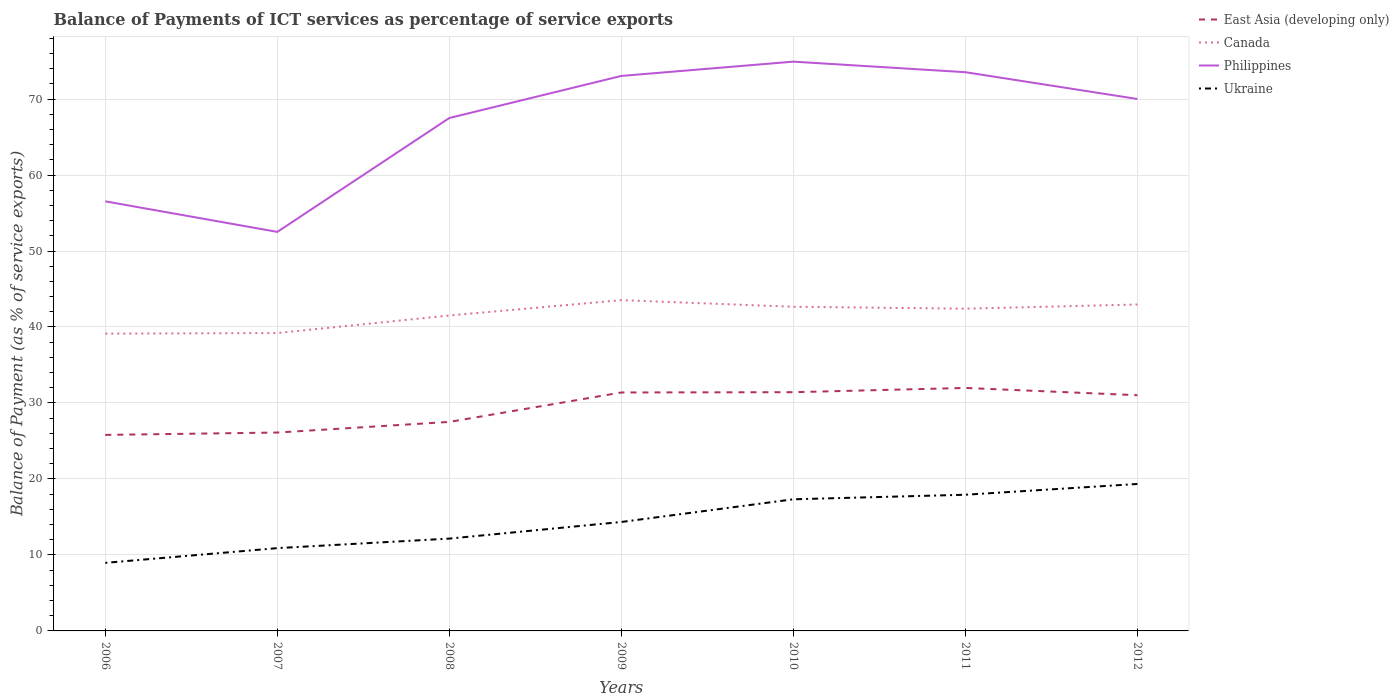Is the number of lines equal to the number of legend labels?
Your response must be concise. Yes. Across all years, what is the maximum balance of payments of ICT services in Canada?
Offer a terse response. 39.12. In which year was the balance of payments of ICT services in Ukraine maximum?
Offer a terse response. 2006. What is the total balance of payments of ICT services in Ukraine in the graph?
Offer a terse response. -0.6. What is the difference between the highest and the second highest balance of payments of ICT services in Canada?
Offer a terse response. 4.41. What is the difference between the highest and the lowest balance of payments of ICT services in East Asia (developing only)?
Ensure brevity in your answer.  4. What is the difference between two consecutive major ticks on the Y-axis?
Give a very brief answer. 10. Are the values on the major ticks of Y-axis written in scientific E-notation?
Your answer should be compact. No. Does the graph contain any zero values?
Provide a short and direct response. No. Does the graph contain grids?
Give a very brief answer. Yes. Where does the legend appear in the graph?
Provide a succinct answer. Top right. How many legend labels are there?
Your answer should be compact. 4. What is the title of the graph?
Provide a short and direct response. Balance of Payments of ICT services as percentage of service exports. What is the label or title of the Y-axis?
Keep it short and to the point. Balance of Payment (as % of service exports). What is the Balance of Payment (as % of service exports) in East Asia (developing only) in 2006?
Your answer should be compact. 25.8. What is the Balance of Payment (as % of service exports) of Canada in 2006?
Offer a very short reply. 39.12. What is the Balance of Payment (as % of service exports) in Philippines in 2006?
Provide a succinct answer. 56.53. What is the Balance of Payment (as % of service exports) of Ukraine in 2006?
Provide a succinct answer. 8.96. What is the Balance of Payment (as % of service exports) of East Asia (developing only) in 2007?
Offer a very short reply. 26.11. What is the Balance of Payment (as % of service exports) in Canada in 2007?
Your answer should be very brief. 39.2. What is the Balance of Payment (as % of service exports) in Philippines in 2007?
Offer a very short reply. 52.51. What is the Balance of Payment (as % of service exports) of Ukraine in 2007?
Make the answer very short. 10.9. What is the Balance of Payment (as % of service exports) in East Asia (developing only) in 2008?
Keep it short and to the point. 27.51. What is the Balance of Payment (as % of service exports) of Canada in 2008?
Your answer should be very brief. 41.51. What is the Balance of Payment (as % of service exports) of Philippines in 2008?
Your response must be concise. 67.5. What is the Balance of Payment (as % of service exports) of Ukraine in 2008?
Offer a terse response. 12.15. What is the Balance of Payment (as % of service exports) in East Asia (developing only) in 2009?
Provide a short and direct response. 31.38. What is the Balance of Payment (as % of service exports) of Canada in 2009?
Provide a short and direct response. 43.53. What is the Balance of Payment (as % of service exports) of Philippines in 2009?
Give a very brief answer. 73.04. What is the Balance of Payment (as % of service exports) in Ukraine in 2009?
Provide a short and direct response. 14.34. What is the Balance of Payment (as % of service exports) of East Asia (developing only) in 2010?
Offer a terse response. 31.42. What is the Balance of Payment (as % of service exports) of Canada in 2010?
Offer a terse response. 42.66. What is the Balance of Payment (as % of service exports) of Philippines in 2010?
Make the answer very short. 74.92. What is the Balance of Payment (as % of service exports) of Ukraine in 2010?
Ensure brevity in your answer.  17.32. What is the Balance of Payment (as % of service exports) in East Asia (developing only) in 2011?
Your answer should be compact. 31.98. What is the Balance of Payment (as % of service exports) of Canada in 2011?
Offer a very short reply. 42.41. What is the Balance of Payment (as % of service exports) of Philippines in 2011?
Keep it short and to the point. 73.53. What is the Balance of Payment (as % of service exports) of Ukraine in 2011?
Give a very brief answer. 17.92. What is the Balance of Payment (as % of service exports) in East Asia (developing only) in 2012?
Your answer should be compact. 31.02. What is the Balance of Payment (as % of service exports) of Canada in 2012?
Ensure brevity in your answer.  42.96. What is the Balance of Payment (as % of service exports) in Philippines in 2012?
Give a very brief answer. 70.01. What is the Balance of Payment (as % of service exports) in Ukraine in 2012?
Provide a succinct answer. 19.34. Across all years, what is the maximum Balance of Payment (as % of service exports) of East Asia (developing only)?
Give a very brief answer. 31.98. Across all years, what is the maximum Balance of Payment (as % of service exports) of Canada?
Make the answer very short. 43.53. Across all years, what is the maximum Balance of Payment (as % of service exports) of Philippines?
Make the answer very short. 74.92. Across all years, what is the maximum Balance of Payment (as % of service exports) in Ukraine?
Your answer should be compact. 19.34. Across all years, what is the minimum Balance of Payment (as % of service exports) of East Asia (developing only)?
Offer a terse response. 25.8. Across all years, what is the minimum Balance of Payment (as % of service exports) of Canada?
Your response must be concise. 39.12. Across all years, what is the minimum Balance of Payment (as % of service exports) of Philippines?
Make the answer very short. 52.51. Across all years, what is the minimum Balance of Payment (as % of service exports) of Ukraine?
Provide a succinct answer. 8.96. What is the total Balance of Payment (as % of service exports) of East Asia (developing only) in the graph?
Offer a terse response. 205.21. What is the total Balance of Payment (as % of service exports) of Canada in the graph?
Your response must be concise. 291.4. What is the total Balance of Payment (as % of service exports) in Philippines in the graph?
Give a very brief answer. 468.05. What is the total Balance of Payment (as % of service exports) of Ukraine in the graph?
Provide a succinct answer. 100.93. What is the difference between the Balance of Payment (as % of service exports) of East Asia (developing only) in 2006 and that in 2007?
Offer a terse response. -0.31. What is the difference between the Balance of Payment (as % of service exports) in Canada in 2006 and that in 2007?
Make the answer very short. -0.08. What is the difference between the Balance of Payment (as % of service exports) of Philippines in 2006 and that in 2007?
Ensure brevity in your answer.  4.02. What is the difference between the Balance of Payment (as % of service exports) in Ukraine in 2006 and that in 2007?
Keep it short and to the point. -1.94. What is the difference between the Balance of Payment (as % of service exports) in East Asia (developing only) in 2006 and that in 2008?
Offer a very short reply. -1.71. What is the difference between the Balance of Payment (as % of service exports) of Canada in 2006 and that in 2008?
Ensure brevity in your answer.  -2.39. What is the difference between the Balance of Payment (as % of service exports) of Philippines in 2006 and that in 2008?
Provide a short and direct response. -10.97. What is the difference between the Balance of Payment (as % of service exports) in Ukraine in 2006 and that in 2008?
Your answer should be very brief. -3.19. What is the difference between the Balance of Payment (as % of service exports) in East Asia (developing only) in 2006 and that in 2009?
Keep it short and to the point. -5.58. What is the difference between the Balance of Payment (as % of service exports) of Canada in 2006 and that in 2009?
Offer a terse response. -4.41. What is the difference between the Balance of Payment (as % of service exports) of Philippines in 2006 and that in 2009?
Provide a succinct answer. -16.51. What is the difference between the Balance of Payment (as % of service exports) of Ukraine in 2006 and that in 2009?
Provide a short and direct response. -5.38. What is the difference between the Balance of Payment (as % of service exports) of East Asia (developing only) in 2006 and that in 2010?
Your response must be concise. -5.62. What is the difference between the Balance of Payment (as % of service exports) in Canada in 2006 and that in 2010?
Provide a short and direct response. -3.54. What is the difference between the Balance of Payment (as % of service exports) in Philippines in 2006 and that in 2010?
Provide a short and direct response. -18.39. What is the difference between the Balance of Payment (as % of service exports) in Ukraine in 2006 and that in 2010?
Offer a very short reply. -8.37. What is the difference between the Balance of Payment (as % of service exports) of East Asia (developing only) in 2006 and that in 2011?
Keep it short and to the point. -6.18. What is the difference between the Balance of Payment (as % of service exports) in Canada in 2006 and that in 2011?
Make the answer very short. -3.29. What is the difference between the Balance of Payment (as % of service exports) of Philippines in 2006 and that in 2011?
Provide a succinct answer. -17. What is the difference between the Balance of Payment (as % of service exports) of Ukraine in 2006 and that in 2011?
Your response must be concise. -8.97. What is the difference between the Balance of Payment (as % of service exports) in East Asia (developing only) in 2006 and that in 2012?
Offer a very short reply. -5.22. What is the difference between the Balance of Payment (as % of service exports) of Canada in 2006 and that in 2012?
Offer a terse response. -3.84. What is the difference between the Balance of Payment (as % of service exports) in Philippines in 2006 and that in 2012?
Make the answer very short. -13.47. What is the difference between the Balance of Payment (as % of service exports) in Ukraine in 2006 and that in 2012?
Offer a very short reply. -10.38. What is the difference between the Balance of Payment (as % of service exports) in East Asia (developing only) in 2007 and that in 2008?
Provide a succinct answer. -1.4. What is the difference between the Balance of Payment (as % of service exports) of Canada in 2007 and that in 2008?
Your response must be concise. -2.31. What is the difference between the Balance of Payment (as % of service exports) of Philippines in 2007 and that in 2008?
Provide a short and direct response. -14.99. What is the difference between the Balance of Payment (as % of service exports) in Ukraine in 2007 and that in 2008?
Make the answer very short. -1.25. What is the difference between the Balance of Payment (as % of service exports) of East Asia (developing only) in 2007 and that in 2009?
Offer a very short reply. -5.27. What is the difference between the Balance of Payment (as % of service exports) of Canada in 2007 and that in 2009?
Make the answer very short. -4.33. What is the difference between the Balance of Payment (as % of service exports) of Philippines in 2007 and that in 2009?
Provide a short and direct response. -20.53. What is the difference between the Balance of Payment (as % of service exports) of Ukraine in 2007 and that in 2009?
Provide a succinct answer. -3.44. What is the difference between the Balance of Payment (as % of service exports) of East Asia (developing only) in 2007 and that in 2010?
Keep it short and to the point. -5.31. What is the difference between the Balance of Payment (as % of service exports) in Canada in 2007 and that in 2010?
Ensure brevity in your answer.  -3.46. What is the difference between the Balance of Payment (as % of service exports) in Philippines in 2007 and that in 2010?
Make the answer very short. -22.41. What is the difference between the Balance of Payment (as % of service exports) of Ukraine in 2007 and that in 2010?
Keep it short and to the point. -6.43. What is the difference between the Balance of Payment (as % of service exports) of East Asia (developing only) in 2007 and that in 2011?
Offer a very short reply. -5.87. What is the difference between the Balance of Payment (as % of service exports) in Canada in 2007 and that in 2011?
Give a very brief answer. -3.2. What is the difference between the Balance of Payment (as % of service exports) in Philippines in 2007 and that in 2011?
Make the answer very short. -21.02. What is the difference between the Balance of Payment (as % of service exports) in Ukraine in 2007 and that in 2011?
Provide a succinct answer. -7.03. What is the difference between the Balance of Payment (as % of service exports) of East Asia (developing only) in 2007 and that in 2012?
Ensure brevity in your answer.  -4.91. What is the difference between the Balance of Payment (as % of service exports) in Canada in 2007 and that in 2012?
Make the answer very short. -3.76. What is the difference between the Balance of Payment (as % of service exports) in Philippines in 2007 and that in 2012?
Ensure brevity in your answer.  -17.49. What is the difference between the Balance of Payment (as % of service exports) of Ukraine in 2007 and that in 2012?
Offer a very short reply. -8.44. What is the difference between the Balance of Payment (as % of service exports) in East Asia (developing only) in 2008 and that in 2009?
Keep it short and to the point. -3.87. What is the difference between the Balance of Payment (as % of service exports) of Canada in 2008 and that in 2009?
Make the answer very short. -2.02. What is the difference between the Balance of Payment (as % of service exports) in Philippines in 2008 and that in 2009?
Give a very brief answer. -5.54. What is the difference between the Balance of Payment (as % of service exports) of Ukraine in 2008 and that in 2009?
Offer a very short reply. -2.19. What is the difference between the Balance of Payment (as % of service exports) in East Asia (developing only) in 2008 and that in 2010?
Offer a terse response. -3.91. What is the difference between the Balance of Payment (as % of service exports) in Canada in 2008 and that in 2010?
Provide a succinct answer. -1.15. What is the difference between the Balance of Payment (as % of service exports) in Philippines in 2008 and that in 2010?
Make the answer very short. -7.42. What is the difference between the Balance of Payment (as % of service exports) of Ukraine in 2008 and that in 2010?
Your answer should be compact. -5.17. What is the difference between the Balance of Payment (as % of service exports) of East Asia (developing only) in 2008 and that in 2011?
Offer a very short reply. -4.47. What is the difference between the Balance of Payment (as % of service exports) in Canada in 2008 and that in 2011?
Provide a succinct answer. -0.9. What is the difference between the Balance of Payment (as % of service exports) in Philippines in 2008 and that in 2011?
Your answer should be very brief. -6.03. What is the difference between the Balance of Payment (as % of service exports) of Ukraine in 2008 and that in 2011?
Your answer should be compact. -5.77. What is the difference between the Balance of Payment (as % of service exports) in East Asia (developing only) in 2008 and that in 2012?
Ensure brevity in your answer.  -3.51. What is the difference between the Balance of Payment (as % of service exports) in Canada in 2008 and that in 2012?
Keep it short and to the point. -1.45. What is the difference between the Balance of Payment (as % of service exports) of Philippines in 2008 and that in 2012?
Provide a short and direct response. -2.5. What is the difference between the Balance of Payment (as % of service exports) in Ukraine in 2008 and that in 2012?
Make the answer very short. -7.19. What is the difference between the Balance of Payment (as % of service exports) in East Asia (developing only) in 2009 and that in 2010?
Your answer should be compact. -0.04. What is the difference between the Balance of Payment (as % of service exports) of Canada in 2009 and that in 2010?
Your answer should be very brief. 0.87. What is the difference between the Balance of Payment (as % of service exports) of Philippines in 2009 and that in 2010?
Ensure brevity in your answer.  -1.88. What is the difference between the Balance of Payment (as % of service exports) in Ukraine in 2009 and that in 2010?
Make the answer very short. -2.99. What is the difference between the Balance of Payment (as % of service exports) in East Asia (developing only) in 2009 and that in 2011?
Your answer should be very brief. -0.6. What is the difference between the Balance of Payment (as % of service exports) in Canada in 2009 and that in 2011?
Provide a short and direct response. 1.12. What is the difference between the Balance of Payment (as % of service exports) in Philippines in 2009 and that in 2011?
Offer a terse response. -0.49. What is the difference between the Balance of Payment (as % of service exports) of Ukraine in 2009 and that in 2011?
Your response must be concise. -3.58. What is the difference between the Balance of Payment (as % of service exports) of East Asia (developing only) in 2009 and that in 2012?
Provide a short and direct response. 0.36. What is the difference between the Balance of Payment (as % of service exports) of Canada in 2009 and that in 2012?
Make the answer very short. 0.57. What is the difference between the Balance of Payment (as % of service exports) of Philippines in 2009 and that in 2012?
Keep it short and to the point. 3.03. What is the difference between the Balance of Payment (as % of service exports) in Ukraine in 2009 and that in 2012?
Ensure brevity in your answer.  -5. What is the difference between the Balance of Payment (as % of service exports) of East Asia (developing only) in 2010 and that in 2011?
Keep it short and to the point. -0.56. What is the difference between the Balance of Payment (as % of service exports) in Canada in 2010 and that in 2011?
Offer a very short reply. 0.25. What is the difference between the Balance of Payment (as % of service exports) in Philippines in 2010 and that in 2011?
Provide a short and direct response. 1.39. What is the difference between the Balance of Payment (as % of service exports) in Ukraine in 2010 and that in 2011?
Ensure brevity in your answer.  -0.6. What is the difference between the Balance of Payment (as % of service exports) of East Asia (developing only) in 2010 and that in 2012?
Offer a terse response. 0.4. What is the difference between the Balance of Payment (as % of service exports) of Canada in 2010 and that in 2012?
Your answer should be very brief. -0.3. What is the difference between the Balance of Payment (as % of service exports) in Philippines in 2010 and that in 2012?
Your response must be concise. 4.92. What is the difference between the Balance of Payment (as % of service exports) of Ukraine in 2010 and that in 2012?
Offer a very short reply. -2.02. What is the difference between the Balance of Payment (as % of service exports) in East Asia (developing only) in 2011 and that in 2012?
Give a very brief answer. 0.96. What is the difference between the Balance of Payment (as % of service exports) in Canada in 2011 and that in 2012?
Give a very brief answer. -0.55. What is the difference between the Balance of Payment (as % of service exports) in Philippines in 2011 and that in 2012?
Your response must be concise. 3.53. What is the difference between the Balance of Payment (as % of service exports) of Ukraine in 2011 and that in 2012?
Offer a very short reply. -1.42. What is the difference between the Balance of Payment (as % of service exports) in East Asia (developing only) in 2006 and the Balance of Payment (as % of service exports) in Canada in 2007?
Give a very brief answer. -13.41. What is the difference between the Balance of Payment (as % of service exports) in East Asia (developing only) in 2006 and the Balance of Payment (as % of service exports) in Philippines in 2007?
Your answer should be compact. -26.72. What is the difference between the Balance of Payment (as % of service exports) in East Asia (developing only) in 2006 and the Balance of Payment (as % of service exports) in Ukraine in 2007?
Give a very brief answer. 14.9. What is the difference between the Balance of Payment (as % of service exports) in Canada in 2006 and the Balance of Payment (as % of service exports) in Philippines in 2007?
Your answer should be compact. -13.39. What is the difference between the Balance of Payment (as % of service exports) of Canada in 2006 and the Balance of Payment (as % of service exports) of Ukraine in 2007?
Your answer should be very brief. 28.23. What is the difference between the Balance of Payment (as % of service exports) of Philippines in 2006 and the Balance of Payment (as % of service exports) of Ukraine in 2007?
Provide a succinct answer. 45.64. What is the difference between the Balance of Payment (as % of service exports) of East Asia (developing only) in 2006 and the Balance of Payment (as % of service exports) of Canada in 2008?
Your response must be concise. -15.71. What is the difference between the Balance of Payment (as % of service exports) of East Asia (developing only) in 2006 and the Balance of Payment (as % of service exports) of Philippines in 2008?
Keep it short and to the point. -41.7. What is the difference between the Balance of Payment (as % of service exports) in East Asia (developing only) in 2006 and the Balance of Payment (as % of service exports) in Ukraine in 2008?
Give a very brief answer. 13.65. What is the difference between the Balance of Payment (as % of service exports) in Canada in 2006 and the Balance of Payment (as % of service exports) in Philippines in 2008?
Your answer should be very brief. -28.38. What is the difference between the Balance of Payment (as % of service exports) of Canada in 2006 and the Balance of Payment (as % of service exports) of Ukraine in 2008?
Keep it short and to the point. 26.97. What is the difference between the Balance of Payment (as % of service exports) of Philippines in 2006 and the Balance of Payment (as % of service exports) of Ukraine in 2008?
Your response must be concise. 44.38. What is the difference between the Balance of Payment (as % of service exports) in East Asia (developing only) in 2006 and the Balance of Payment (as % of service exports) in Canada in 2009?
Keep it short and to the point. -17.73. What is the difference between the Balance of Payment (as % of service exports) of East Asia (developing only) in 2006 and the Balance of Payment (as % of service exports) of Philippines in 2009?
Make the answer very short. -47.24. What is the difference between the Balance of Payment (as % of service exports) in East Asia (developing only) in 2006 and the Balance of Payment (as % of service exports) in Ukraine in 2009?
Ensure brevity in your answer.  11.46. What is the difference between the Balance of Payment (as % of service exports) in Canada in 2006 and the Balance of Payment (as % of service exports) in Philippines in 2009?
Your answer should be very brief. -33.92. What is the difference between the Balance of Payment (as % of service exports) of Canada in 2006 and the Balance of Payment (as % of service exports) of Ukraine in 2009?
Offer a very short reply. 24.78. What is the difference between the Balance of Payment (as % of service exports) in Philippines in 2006 and the Balance of Payment (as % of service exports) in Ukraine in 2009?
Keep it short and to the point. 42.2. What is the difference between the Balance of Payment (as % of service exports) of East Asia (developing only) in 2006 and the Balance of Payment (as % of service exports) of Canada in 2010?
Provide a short and direct response. -16.86. What is the difference between the Balance of Payment (as % of service exports) in East Asia (developing only) in 2006 and the Balance of Payment (as % of service exports) in Philippines in 2010?
Provide a short and direct response. -49.12. What is the difference between the Balance of Payment (as % of service exports) of East Asia (developing only) in 2006 and the Balance of Payment (as % of service exports) of Ukraine in 2010?
Your response must be concise. 8.47. What is the difference between the Balance of Payment (as % of service exports) in Canada in 2006 and the Balance of Payment (as % of service exports) in Philippines in 2010?
Keep it short and to the point. -35.8. What is the difference between the Balance of Payment (as % of service exports) of Canada in 2006 and the Balance of Payment (as % of service exports) of Ukraine in 2010?
Your answer should be compact. 21.8. What is the difference between the Balance of Payment (as % of service exports) in Philippines in 2006 and the Balance of Payment (as % of service exports) in Ukraine in 2010?
Make the answer very short. 39.21. What is the difference between the Balance of Payment (as % of service exports) in East Asia (developing only) in 2006 and the Balance of Payment (as % of service exports) in Canada in 2011?
Provide a succinct answer. -16.61. What is the difference between the Balance of Payment (as % of service exports) of East Asia (developing only) in 2006 and the Balance of Payment (as % of service exports) of Philippines in 2011?
Your answer should be very brief. -47.73. What is the difference between the Balance of Payment (as % of service exports) of East Asia (developing only) in 2006 and the Balance of Payment (as % of service exports) of Ukraine in 2011?
Provide a short and direct response. 7.88. What is the difference between the Balance of Payment (as % of service exports) in Canada in 2006 and the Balance of Payment (as % of service exports) in Philippines in 2011?
Your answer should be very brief. -34.41. What is the difference between the Balance of Payment (as % of service exports) of Canada in 2006 and the Balance of Payment (as % of service exports) of Ukraine in 2011?
Provide a short and direct response. 21.2. What is the difference between the Balance of Payment (as % of service exports) in Philippines in 2006 and the Balance of Payment (as % of service exports) in Ukraine in 2011?
Provide a short and direct response. 38.61. What is the difference between the Balance of Payment (as % of service exports) of East Asia (developing only) in 2006 and the Balance of Payment (as % of service exports) of Canada in 2012?
Make the answer very short. -17.16. What is the difference between the Balance of Payment (as % of service exports) of East Asia (developing only) in 2006 and the Balance of Payment (as % of service exports) of Philippines in 2012?
Your response must be concise. -44.21. What is the difference between the Balance of Payment (as % of service exports) of East Asia (developing only) in 2006 and the Balance of Payment (as % of service exports) of Ukraine in 2012?
Make the answer very short. 6.46. What is the difference between the Balance of Payment (as % of service exports) of Canada in 2006 and the Balance of Payment (as % of service exports) of Philippines in 2012?
Make the answer very short. -30.88. What is the difference between the Balance of Payment (as % of service exports) of Canada in 2006 and the Balance of Payment (as % of service exports) of Ukraine in 2012?
Provide a short and direct response. 19.78. What is the difference between the Balance of Payment (as % of service exports) in Philippines in 2006 and the Balance of Payment (as % of service exports) in Ukraine in 2012?
Provide a succinct answer. 37.19. What is the difference between the Balance of Payment (as % of service exports) in East Asia (developing only) in 2007 and the Balance of Payment (as % of service exports) in Canada in 2008?
Give a very brief answer. -15.4. What is the difference between the Balance of Payment (as % of service exports) in East Asia (developing only) in 2007 and the Balance of Payment (as % of service exports) in Philippines in 2008?
Offer a terse response. -41.39. What is the difference between the Balance of Payment (as % of service exports) in East Asia (developing only) in 2007 and the Balance of Payment (as % of service exports) in Ukraine in 2008?
Provide a succinct answer. 13.96. What is the difference between the Balance of Payment (as % of service exports) of Canada in 2007 and the Balance of Payment (as % of service exports) of Philippines in 2008?
Make the answer very short. -28.3. What is the difference between the Balance of Payment (as % of service exports) in Canada in 2007 and the Balance of Payment (as % of service exports) in Ukraine in 2008?
Make the answer very short. 27.05. What is the difference between the Balance of Payment (as % of service exports) in Philippines in 2007 and the Balance of Payment (as % of service exports) in Ukraine in 2008?
Make the answer very short. 40.36. What is the difference between the Balance of Payment (as % of service exports) of East Asia (developing only) in 2007 and the Balance of Payment (as % of service exports) of Canada in 2009?
Make the answer very short. -17.42. What is the difference between the Balance of Payment (as % of service exports) of East Asia (developing only) in 2007 and the Balance of Payment (as % of service exports) of Philippines in 2009?
Your response must be concise. -46.93. What is the difference between the Balance of Payment (as % of service exports) of East Asia (developing only) in 2007 and the Balance of Payment (as % of service exports) of Ukraine in 2009?
Your answer should be very brief. 11.77. What is the difference between the Balance of Payment (as % of service exports) in Canada in 2007 and the Balance of Payment (as % of service exports) in Philippines in 2009?
Ensure brevity in your answer.  -33.84. What is the difference between the Balance of Payment (as % of service exports) in Canada in 2007 and the Balance of Payment (as % of service exports) in Ukraine in 2009?
Provide a succinct answer. 24.87. What is the difference between the Balance of Payment (as % of service exports) of Philippines in 2007 and the Balance of Payment (as % of service exports) of Ukraine in 2009?
Keep it short and to the point. 38.18. What is the difference between the Balance of Payment (as % of service exports) in East Asia (developing only) in 2007 and the Balance of Payment (as % of service exports) in Canada in 2010?
Ensure brevity in your answer.  -16.55. What is the difference between the Balance of Payment (as % of service exports) in East Asia (developing only) in 2007 and the Balance of Payment (as % of service exports) in Philippines in 2010?
Keep it short and to the point. -48.81. What is the difference between the Balance of Payment (as % of service exports) in East Asia (developing only) in 2007 and the Balance of Payment (as % of service exports) in Ukraine in 2010?
Make the answer very short. 8.78. What is the difference between the Balance of Payment (as % of service exports) in Canada in 2007 and the Balance of Payment (as % of service exports) in Philippines in 2010?
Offer a terse response. -35.72. What is the difference between the Balance of Payment (as % of service exports) of Canada in 2007 and the Balance of Payment (as % of service exports) of Ukraine in 2010?
Your answer should be compact. 21.88. What is the difference between the Balance of Payment (as % of service exports) of Philippines in 2007 and the Balance of Payment (as % of service exports) of Ukraine in 2010?
Ensure brevity in your answer.  35.19. What is the difference between the Balance of Payment (as % of service exports) of East Asia (developing only) in 2007 and the Balance of Payment (as % of service exports) of Canada in 2011?
Your response must be concise. -16.3. What is the difference between the Balance of Payment (as % of service exports) in East Asia (developing only) in 2007 and the Balance of Payment (as % of service exports) in Philippines in 2011?
Provide a short and direct response. -47.42. What is the difference between the Balance of Payment (as % of service exports) in East Asia (developing only) in 2007 and the Balance of Payment (as % of service exports) in Ukraine in 2011?
Make the answer very short. 8.19. What is the difference between the Balance of Payment (as % of service exports) in Canada in 2007 and the Balance of Payment (as % of service exports) in Philippines in 2011?
Give a very brief answer. -34.33. What is the difference between the Balance of Payment (as % of service exports) of Canada in 2007 and the Balance of Payment (as % of service exports) of Ukraine in 2011?
Offer a terse response. 21.28. What is the difference between the Balance of Payment (as % of service exports) in Philippines in 2007 and the Balance of Payment (as % of service exports) in Ukraine in 2011?
Provide a succinct answer. 34.59. What is the difference between the Balance of Payment (as % of service exports) of East Asia (developing only) in 2007 and the Balance of Payment (as % of service exports) of Canada in 2012?
Your answer should be very brief. -16.85. What is the difference between the Balance of Payment (as % of service exports) in East Asia (developing only) in 2007 and the Balance of Payment (as % of service exports) in Philippines in 2012?
Your response must be concise. -43.9. What is the difference between the Balance of Payment (as % of service exports) in East Asia (developing only) in 2007 and the Balance of Payment (as % of service exports) in Ukraine in 2012?
Keep it short and to the point. 6.77. What is the difference between the Balance of Payment (as % of service exports) of Canada in 2007 and the Balance of Payment (as % of service exports) of Philippines in 2012?
Keep it short and to the point. -30.8. What is the difference between the Balance of Payment (as % of service exports) of Canada in 2007 and the Balance of Payment (as % of service exports) of Ukraine in 2012?
Provide a succinct answer. 19.86. What is the difference between the Balance of Payment (as % of service exports) in Philippines in 2007 and the Balance of Payment (as % of service exports) in Ukraine in 2012?
Provide a short and direct response. 33.17. What is the difference between the Balance of Payment (as % of service exports) of East Asia (developing only) in 2008 and the Balance of Payment (as % of service exports) of Canada in 2009?
Provide a succinct answer. -16.02. What is the difference between the Balance of Payment (as % of service exports) of East Asia (developing only) in 2008 and the Balance of Payment (as % of service exports) of Philippines in 2009?
Your answer should be very brief. -45.53. What is the difference between the Balance of Payment (as % of service exports) in East Asia (developing only) in 2008 and the Balance of Payment (as % of service exports) in Ukraine in 2009?
Offer a terse response. 13.17. What is the difference between the Balance of Payment (as % of service exports) of Canada in 2008 and the Balance of Payment (as % of service exports) of Philippines in 2009?
Your answer should be compact. -31.53. What is the difference between the Balance of Payment (as % of service exports) in Canada in 2008 and the Balance of Payment (as % of service exports) in Ukraine in 2009?
Your answer should be very brief. 27.17. What is the difference between the Balance of Payment (as % of service exports) in Philippines in 2008 and the Balance of Payment (as % of service exports) in Ukraine in 2009?
Keep it short and to the point. 53.16. What is the difference between the Balance of Payment (as % of service exports) of East Asia (developing only) in 2008 and the Balance of Payment (as % of service exports) of Canada in 2010?
Provide a short and direct response. -15.15. What is the difference between the Balance of Payment (as % of service exports) in East Asia (developing only) in 2008 and the Balance of Payment (as % of service exports) in Philippines in 2010?
Give a very brief answer. -47.41. What is the difference between the Balance of Payment (as % of service exports) in East Asia (developing only) in 2008 and the Balance of Payment (as % of service exports) in Ukraine in 2010?
Ensure brevity in your answer.  10.18. What is the difference between the Balance of Payment (as % of service exports) of Canada in 2008 and the Balance of Payment (as % of service exports) of Philippines in 2010?
Your response must be concise. -33.41. What is the difference between the Balance of Payment (as % of service exports) of Canada in 2008 and the Balance of Payment (as % of service exports) of Ukraine in 2010?
Offer a very short reply. 24.19. What is the difference between the Balance of Payment (as % of service exports) in Philippines in 2008 and the Balance of Payment (as % of service exports) in Ukraine in 2010?
Keep it short and to the point. 50.18. What is the difference between the Balance of Payment (as % of service exports) in East Asia (developing only) in 2008 and the Balance of Payment (as % of service exports) in Canada in 2011?
Give a very brief answer. -14.9. What is the difference between the Balance of Payment (as % of service exports) of East Asia (developing only) in 2008 and the Balance of Payment (as % of service exports) of Philippines in 2011?
Provide a short and direct response. -46.02. What is the difference between the Balance of Payment (as % of service exports) in East Asia (developing only) in 2008 and the Balance of Payment (as % of service exports) in Ukraine in 2011?
Make the answer very short. 9.59. What is the difference between the Balance of Payment (as % of service exports) of Canada in 2008 and the Balance of Payment (as % of service exports) of Philippines in 2011?
Your answer should be compact. -32.02. What is the difference between the Balance of Payment (as % of service exports) of Canada in 2008 and the Balance of Payment (as % of service exports) of Ukraine in 2011?
Ensure brevity in your answer.  23.59. What is the difference between the Balance of Payment (as % of service exports) in Philippines in 2008 and the Balance of Payment (as % of service exports) in Ukraine in 2011?
Your answer should be compact. 49.58. What is the difference between the Balance of Payment (as % of service exports) of East Asia (developing only) in 2008 and the Balance of Payment (as % of service exports) of Canada in 2012?
Give a very brief answer. -15.45. What is the difference between the Balance of Payment (as % of service exports) of East Asia (developing only) in 2008 and the Balance of Payment (as % of service exports) of Philippines in 2012?
Provide a short and direct response. -42.5. What is the difference between the Balance of Payment (as % of service exports) of East Asia (developing only) in 2008 and the Balance of Payment (as % of service exports) of Ukraine in 2012?
Keep it short and to the point. 8.17. What is the difference between the Balance of Payment (as % of service exports) of Canada in 2008 and the Balance of Payment (as % of service exports) of Philippines in 2012?
Your answer should be compact. -28.5. What is the difference between the Balance of Payment (as % of service exports) of Canada in 2008 and the Balance of Payment (as % of service exports) of Ukraine in 2012?
Make the answer very short. 22.17. What is the difference between the Balance of Payment (as % of service exports) of Philippines in 2008 and the Balance of Payment (as % of service exports) of Ukraine in 2012?
Ensure brevity in your answer.  48.16. What is the difference between the Balance of Payment (as % of service exports) of East Asia (developing only) in 2009 and the Balance of Payment (as % of service exports) of Canada in 2010?
Make the answer very short. -11.28. What is the difference between the Balance of Payment (as % of service exports) in East Asia (developing only) in 2009 and the Balance of Payment (as % of service exports) in Philippines in 2010?
Offer a terse response. -43.54. What is the difference between the Balance of Payment (as % of service exports) of East Asia (developing only) in 2009 and the Balance of Payment (as % of service exports) of Ukraine in 2010?
Your response must be concise. 14.06. What is the difference between the Balance of Payment (as % of service exports) of Canada in 2009 and the Balance of Payment (as % of service exports) of Philippines in 2010?
Ensure brevity in your answer.  -31.39. What is the difference between the Balance of Payment (as % of service exports) in Canada in 2009 and the Balance of Payment (as % of service exports) in Ukraine in 2010?
Make the answer very short. 26.21. What is the difference between the Balance of Payment (as % of service exports) of Philippines in 2009 and the Balance of Payment (as % of service exports) of Ukraine in 2010?
Provide a short and direct response. 55.72. What is the difference between the Balance of Payment (as % of service exports) of East Asia (developing only) in 2009 and the Balance of Payment (as % of service exports) of Canada in 2011?
Keep it short and to the point. -11.03. What is the difference between the Balance of Payment (as % of service exports) of East Asia (developing only) in 2009 and the Balance of Payment (as % of service exports) of Philippines in 2011?
Your response must be concise. -42.15. What is the difference between the Balance of Payment (as % of service exports) in East Asia (developing only) in 2009 and the Balance of Payment (as % of service exports) in Ukraine in 2011?
Ensure brevity in your answer.  13.46. What is the difference between the Balance of Payment (as % of service exports) of Canada in 2009 and the Balance of Payment (as % of service exports) of Philippines in 2011?
Your response must be concise. -30. What is the difference between the Balance of Payment (as % of service exports) of Canada in 2009 and the Balance of Payment (as % of service exports) of Ukraine in 2011?
Your response must be concise. 25.61. What is the difference between the Balance of Payment (as % of service exports) in Philippines in 2009 and the Balance of Payment (as % of service exports) in Ukraine in 2011?
Make the answer very short. 55.12. What is the difference between the Balance of Payment (as % of service exports) of East Asia (developing only) in 2009 and the Balance of Payment (as % of service exports) of Canada in 2012?
Ensure brevity in your answer.  -11.58. What is the difference between the Balance of Payment (as % of service exports) in East Asia (developing only) in 2009 and the Balance of Payment (as % of service exports) in Philippines in 2012?
Ensure brevity in your answer.  -38.63. What is the difference between the Balance of Payment (as % of service exports) of East Asia (developing only) in 2009 and the Balance of Payment (as % of service exports) of Ukraine in 2012?
Ensure brevity in your answer.  12.04. What is the difference between the Balance of Payment (as % of service exports) in Canada in 2009 and the Balance of Payment (as % of service exports) in Philippines in 2012?
Offer a very short reply. -26.48. What is the difference between the Balance of Payment (as % of service exports) in Canada in 2009 and the Balance of Payment (as % of service exports) in Ukraine in 2012?
Provide a succinct answer. 24.19. What is the difference between the Balance of Payment (as % of service exports) in Philippines in 2009 and the Balance of Payment (as % of service exports) in Ukraine in 2012?
Provide a short and direct response. 53.7. What is the difference between the Balance of Payment (as % of service exports) in East Asia (developing only) in 2010 and the Balance of Payment (as % of service exports) in Canada in 2011?
Give a very brief answer. -10.99. What is the difference between the Balance of Payment (as % of service exports) of East Asia (developing only) in 2010 and the Balance of Payment (as % of service exports) of Philippines in 2011?
Offer a terse response. -42.11. What is the difference between the Balance of Payment (as % of service exports) of East Asia (developing only) in 2010 and the Balance of Payment (as % of service exports) of Ukraine in 2011?
Give a very brief answer. 13.5. What is the difference between the Balance of Payment (as % of service exports) in Canada in 2010 and the Balance of Payment (as % of service exports) in Philippines in 2011?
Keep it short and to the point. -30.87. What is the difference between the Balance of Payment (as % of service exports) in Canada in 2010 and the Balance of Payment (as % of service exports) in Ukraine in 2011?
Offer a terse response. 24.74. What is the difference between the Balance of Payment (as % of service exports) of Philippines in 2010 and the Balance of Payment (as % of service exports) of Ukraine in 2011?
Provide a short and direct response. 57. What is the difference between the Balance of Payment (as % of service exports) of East Asia (developing only) in 2010 and the Balance of Payment (as % of service exports) of Canada in 2012?
Offer a very short reply. -11.54. What is the difference between the Balance of Payment (as % of service exports) of East Asia (developing only) in 2010 and the Balance of Payment (as % of service exports) of Philippines in 2012?
Provide a succinct answer. -38.59. What is the difference between the Balance of Payment (as % of service exports) of East Asia (developing only) in 2010 and the Balance of Payment (as % of service exports) of Ukraine in 2012?
Provide a short and direct response. 12.08. What is the difference between the Balance of Payment (as % of service exports) of Canada in 2010 and the Balance of Payment (as % of service exports) of Philippines in 2012?
Give a very brief answer. -27.34. What is the difference between the Balance of Payment (as % of service exports) of Canada in 2010 and the Balance of Payment (as % of service exports) of Ukraine in 2012?
Your answer should be very brief. 23.32. What is the difference between the Balance of Payment (as % of service exports) of Philippines in 2010 and the Balance of Payment (as % of service exports) of Ukraine in 2012?
Provide a succinct answer. 55.58. What is the difference between the Balance of Payment (as % of service exports) of East Asia (developing only) in 2011 and the Balance of Payment (as % of service exports) of Canada in 2012?
Make the answer very short. -10.98. What is the difference between the Balance of Payment (as % of service exports) of East Asia (developing only) in 2011 and the Balance of Payment (as % of service exports) of Philippines in 2012?
Make the answer very short. -38.03. What is the difference between the Balance of Payment (as % of service exports) of East Asia (developing only) in 2011 and the Balance of Payment (as % of service exports) of Ukraine in 2012?
Provide a short and direct response. 12.64. What is the difference between the Balance of Payment (as % of service exports) of Canada in 2011 and the Balance of Payment (as % of service exports) of Philippines in 2012?
Give a very brief answer. -27.6. What is the difference between the Balance of Payment (as % of service exports) in Canada in 2011 and the Balance of Payment (as % of service exports) in Ukraine in 2012?
Ensure brevity in your answer.  23.07. What is the difference between the Balance of Payment (as % of service exports) in Philippines in 2011 and the Balance of Payment (as % of service exports) in Ukraine in 2012?
Give a very brief answer. 54.19. What is the average Balance of Payment (as % of service exports) in East Asia (developing only) per year?
Your answer should be compact. 29.32. What is the average Balance of Payment (as % of service exports) of Canada per year?
Keep it short and to the point. 41.63. What is the average Balance of Payment (as % of service exports) in Philippines per year?
Offer a very short reply. 66.86. What is the average Balance of Payment (as % of service exports) of Ukraine per year?
Ensure brevity in your answer.  14.42. In the year 2006, what is the difference between the Balance of Payment (as % of service exports) of East Asia (developing only) and Balance of Payment (as % of service exports) of Canada?
Offer a terse response. -13.32. In the year 2006, what is the difference between the Balance of Payment (as % of service exports) in East Asia (developing only) and Balance of Payment (as % of service exports) in Philippines?
Keep it short and to the point. -30.74. In the year 2006, what is the difference between the Balance of Payment (as % of service exports) in East Asia (developing only) and Balance of Payment (as % of service exports) in Ukraine?
Give a very brief answer. 16.84. In the year 2006, what is the difference between the Balance of Payment (as % of service exports) of Canada and Balance of Payment (as % of service exports) of Philippines?
Your answer should be very brief. -17.41. In the year 2006, what is the difference between the Balance of Payment (as % of service exports) in Canada and Balance of Payment (as % of service exports) in Ukraine?
Make the answer very short. 30.17. In the year 2006, what is the difference between the Balance of Payment (as % of service exports) in Philippines and Balance of Payment (as % of service exports) in Ukraine?
Give a very brief answer. 47.58. In the year 2007, what is the difference between the Balance of Payment (as % of service exports) of East Asia (developing only) and Balance of Payment (as % of service exports) of Canada?
Your response must be concise. -13.09. In the year 2007, what is the difference between the Balance of Payment (as % of service exports) in East Asia (developing only) and Balance of Payment (as % of service exports) in Philippines?
Your answer should be very brief. -26.41. In the year 2007, what is the difference between the Balance of Payment (as % of service exports) in East Asia (developing only) and Balance of Payment (as % of service exports) in Ukraine?
Provide a succinct answer. 15.21. In the year 2007, what is the difference between the Balance of Payment (as % of service exports) of Canada and Balance of Payment (as % of service exports) of Philippines?
Offer a terse response. -13.31. In the year 2007, what is the difference between the Balance of Payment (as % of service exports) of Canada and Balance of Payment (as % of service exports) of Ukraine?
Ensure brevity in your answer.  28.31. In the year 2007, what is the difference between the Balance of Payment (as % of service exports) in Philippines and Balance of Payment (as % of service exports) in Ukraine?
Ensure brevity in your answer.  41.62. In the year 2008, what is the difference between the Balance of Payment (as % of service exports) of East Asia (developing only) and Balance of Payment (as % of service exports) of Canada?
Provide a short and direct response. -14. In the year 2008, what is the difference between the Balance of Payment (as % of service exports) in East Asia (developing only) and Balance of Payment (as % of service exports) in Philippines?
Make the answer very short. -39.99. In the year 2008, what is the difference between the Balance of Payment (as % of service exports) in East Asia (developing only) and Balance of Payment (as % of service exports) in Ukraine?
Your response must be concise. 15.36. In the year 2008, what is the difference between the Balance of Payment (as % of service exports) of Canada and Balance of Payment (as % of service exports) of Philippines?
Ensure brevity in your answer.  -25.99. In the year 2008, what is the difference between the Balance of Payment (as % of service exports) of Canada and Balance of Payment (as % of service exports) of Ukraine?
Ensure brevity in your answer.  29.36. In the year 2008, what is the difference between the Balance of Payment (as % of service exports) of Philippines and Balance of Payment (as % of service exports) of Ukraine?
Keep it short and to the point. 55.35. In the year 2009, what is the difference between the Balance of Payment (as % of service exports) of East Asia (developing only) and Balance of Payment (as % of service exports) of Canada?
Make the answer very short. -12.15. In the year 2009, what is the difference between the Balance of Payment (as % of service exports) of East Asia (developing only) and Balance of Payment (as % of service exports) of Philippines?
Make the answer very short. -41.66. In the year 2009, what is the difference between the Balance of Payment (as % of service exports) of East Asia (developing only) and Balance of Payment (as % of service exports) of Ukraine?
Make the answer very short. 17.04. In the year 2009, what is the difference between the Balance of Payment (as % of service exports) of Canada and Balance of Payment (as % of service exports) of Philippines?
Provide a short and direct response. -29.51. In the year 2009, what is the difference between the Balance of Payment (as % of service exports) in Canada and Balance of Payment (as % of service exports) in Ukraine?
Ensure brevity in your answer.  29.19. In the year 2009, what is the difference between the Balance of Payment (as % of service exports) of Philippines and Balance of Payment (as % of service exports) of Ukraine?
Your answer should be compact. 58.7. In the year 2010, what is the difference between the Balance of Payment (as % of service exports) in East Asia (developing only) and Balance of Payment (as % of service exports) in Canada?
Your response must be concise. -11.24. In the year 2010, what is the difference between the Balance of Payment (as % of service exports) in East Asia (developing only) and Balance of Payment (as % of service exports) in Philippines?
Keep it short and to the point. -43.5. In the year 2010, what is the difference between the Balance of Payment (as % of service exports) in East Asia (developing only) and Balance of Payment (as % of service exports) in Ukraine?
Offer a very short reply. 14.09. In the year 2010, what is the difference between the Balance of Payment (as % of service exports) in Canada and Balance of Payment (as % of service exports) in Philippines?
Make the answer very short. -32.26. In the year 2010, what is the difference between the Balance of Payment (as % of service exports) in Canada and Balance of Payment (as % of service exports) in Ukraine?
Make the answer very short. 25.34. In the year 2010, what is the difference between the Balance of Payment (as % of service exports) in Philippines and Balance of Payment (as % of service exports) in Ukraine?
Offer a very short reply. 57.6. In the year 2011, what is the difference between the Balance of Payment (as % of service exports) of East Asia (developing only) and Balance of Payment (as % of service exports) of Canada?
Ensure brevity in your answer.  -10.43. In the year 2011, what is the difference between the Balance of Payment (as % of service exports) of East Asia (developing only) and Balance of Payment (as % of service exports) of Philippines?
Your answer should be very brief. -41.55. In the year 2011, what is the difference between the Balance of Payment (as % of service exports) of East Asia (developing only) and Balance of Payment (as % of service exports) of Ukraine?
Ensure brevity in your answer.  14.06. In the year 2011, what is the difference between the Balance of Payment (as % of service exports) of Canada and Balance of Payment (as % of service exports) of Philippines?
Provide a succinct answer. -31.12. In the year 2011, what is the difference between the Balance of Payment (as % of service exports) in Canada and Balance of Payment (as % of service exports) in Ukraine?
Ensure brevity in your answer.  24.49. In the year 2011, what is the difference between the Balance of Payment (as % of service exports) of Philippines and Balance of Payment (as % of service exports) of Ukraine?
Your answer should be compact. 55.61. In the year 2012, what is the difference between the Balance of Payment (as % of service exports) in East Asia (developing only) and Balance of Payment (as % of service exports) in Canada?
Offer a terse response. -11.94. In the year 2012, what is the difference between the Balance of Payment (as % of service exports) of East Asia (developing only) and Balance of Payment (as % of service exports) of Philippines?
Offer a terse response. -38.98. In the year 2012, what is the difference between the Balance of Payment (as % of service exports) in East Asia (developing only) and Balance of Payment (as % of service exports) in Ukraine?
Offer a very short reply. 11.68. In the year 2012, what is the difference between the Balance of Payment (as % of service exports) of Canada and Balance of Payment (as % of service exports) of Philippines?
Keep it short and to the point. -27.05. In the year 2012, what is the difference between the Balance of Payment (as % of service exports) of Canada and Balance of Payment (as % of service exports) of Ukraine?
Provide a succinct answer. 23.62. In the year 2012, what is the difference between the Balance of Payment (as % of service exports) in Philippines and Balance of Payment (as % of service exports) in Ukraine?
Provide a short and direct response. 50.67. What is the ratio of the Balance of Payment (as % of service exports) in East Asia (developing only) in 2006 to that in 2007?
Ensure brevity in your answer.  0.99. What is the ratio of the Balance of Payment (as % of service exports) in Canada in 2006 to that in 2007?
Give a very brief answer. 1. What is the ratio of the Balance of Payment (as % of service exports) of Philippines in 2006 to that in 2007?
Your response must be concise. 1.08. What is the ratio of the Balance of Payment (as % of service exports) in Ukraine in 2006 to that in 2007?
Your answer should be compact. 0.82. What is the ratio of the Balance of Payment (as % of service exports) of East Asia (developing only) in 2006 to that in 2008?
Provide a succinct answer. 0.94. What is the ratio of the Balance of Payment (as % of service exports) of Canada in 2006 to that in 2008?
Provide a short and direct response. 0.94. What is the ratio of the Balance of Payment (as % of service exports) of Philippines in 2006 to that in 2008?
Make the answer very short. 0.84. What is the ratio of the Balance of Payment (as % of service exports) in Ukraine in 2006 to that in 2008?
Your answer should be compact. 0.74. What is the ratio of the Balance of Payment (as % of service exports) in East Asia (developing only) in 2006 to that in 2009?
Offer a very short reply. 0.82. What is the ratio of the Balance of Payment (as % of service exports) in Canada in 2006 to that in 2009?
Keep it short and to the point. 0.9. What is the ratio of the Balance of Payment (as % of service exports) of Philippines in 2006 to that in 2009?
Make the answer very short. 0.77. What is the ratio of the Balance of Payment (as % of service exports) of Ukraine in 2006 to that in 2009?
Ensure brevity in your answer.  0.62. What is the ratio of the Balance of Payment (as % of service exports) in East Asia (developing only) in 2006 to that in 2010?
Ensure brevity in your answer.  0.82. What is the ratio of the Balance of Payment (as % of service exports) of Canada in 2006 to that in 2010?
Offer a very short reply. 0.92. What is the ratio of the Balance of Payment (as % of service exports) in Philippines in 2006 to that in 2010?
Provide a succinct answer. 0.75. What is the ratio of the Balance of Payment (as % of service exports) in Ukraine in 2006 to that in 2010?
Your answer should be very brief. 0.52. What is the ratio of the Balance of Payment (as % of service exports) of East Asia (developing only) in 2006 to that in 2011?
Your answer should be compact. 0.81. What is the ratio of the Balance of Payment (as % of service exports) in Canada in 2006 to that in 2011?
Keep it short and to the point. 0.92. What is the ratio of the Balance of Payment (as % of service exports) of Philippines in 2006 to that in 2011?
Make the answer very short. 0.77. What is the ratio of the Balance of Payment (as % of service exports) of Ukraine in 2006 to that in 2011?
Your answer should be very brief. 0.5. What is the ratio of the Balance of Payment (as % of service exports) of East Asia (developing only) in 2006 to that in 2012?
Ensure brevity in your answer.  0.83. What is the ratio of the Balance of Payment (as % of service exports) of Canada in 2006 to that in 2012?
Your answer should be very brief. 0.91. What is the ratio of the Balance of Payment (as % of service exports) of Philippines in 2006 to that in 2012?
Keep it short and to the point. 0.81. What is the ratio of the Balance of Payment (as % of service exports) of Ukraine in 2006 to that in 2012?
Give a very brief answer. 0.46. What is the ratio of the Balance of Payment (as % of service exports) of East Asia (developing only) in 2007 to that in 2008?
Make the answer very short. 0.95. What is the ratio of the Balance of Payment (as % of service exports) in Philippines in 2007 to that in 2008?
Provide a succinct answer. 0.78. What is the ratio of the Balance of Payment (as % of service exports) in Ukraine in 2007 to that in 2008?
Provide a short and direct response. 0.9. What is the ratio of the Balance of Payment (as % of service exports) in East Asia (developing only) in 2007 to that in 2009?
Give a very brief answer. 0.83. What is the ratio of the Balance of Payment (as % of service exports) of Canada in 2007 to that in 2009?
Provide a succinct answer. 0.9. What is the ratio of the Balance of Payment (as % of service exports) of Philippines in 2007 to that in 2009?
Your answer should be very brief. 0.72. What is the ratio of the Balance of Payment (as % of service exports) of Ukraine in 2007 to that in 2009?
Make the answer very short. 0.76. What is the ratio of the Balance of Payment (as % of service exports) in East Asia (developing only) in 2007 to that in 2010?
Your answer should be compact. 0.83. What is the ratio of the Balance of Payment (as % of service exports) in Canada in 2007 to that in 2010?
Ensure brevity in your answer.  0.92. What is the ratio of the Balance of Payment (as % of service exports) of Philippines in 2007 to that in 2010?
Provide a short and direct response. 0.7. What is the ratio of the Balance of Payment (as % of service exports) of Ukraine in 2007 to that in 2010?
Make the answer very short. 0.63. What is the ratio of the Balance of Payment (as % of service exports) in East Asia (developing only) in 2007 to that in 2011?
Provide a succinct answer. 0.82. What is the ratio of the Balance of Payment (as % of service exports) of Canada in 2007 to that in 2011?
Your response must be concise. 0.92. What is the ratio of the Balance of Payment (as % of service exports) of Philippines in 2007 to that in 2011?
Your answer should be compact. 0.71. What is the ratio of the Balance of Payment (as % of service exports) of Ukraine in 2007 to that in 2011?
Your answer should be compact. 0.61. What is the ratio of the Balance of Payment (as % of service exports) in East Asia (developing only) in 2007 to that in 2012?
Ensure brevity in your answer.  0.84. What is the ratio of the Balance of Payment (as % of service exports) in Canada in 2007 to that in 2012?
Your answer should be very brief. 0.91. What is the ratio of the Balance of Payment (as % of service exports) in Philippines in 2007 to that in 2012?
Provide a succinct answer. 0.75. What is the ratio of the Balance of Payment (as % of service exports) of Ukraine in 2007 to that in 2012?
Make the answer very short. 0.56. What is the ratio of the Balance of Payment (as % of service exports) of East Asia (developing only) in 2008 to that in 2009?
Provide a succinct answer. 0.88. What is the ratio of the Balance of Payment (as % of service exports) in Canada in 2008 to that in 2009?
Provide a short and direct response. 0.95. What is the ratio of the Balance of Payment (as % of service exports) in Philippines in 2008 to that in 2009?
Offer a terse response. 0.92. What is the ratio of the Balance of Payment (as % of service exports) of Ukraine in 2008 to that in 2009?
Offer a very short reply. 0.85. What is the ratio of the Balance of Payment (as % of service exports) of East Asia (developing only) in 2008 to that in 2010?
Ensure brevity in your answer.  0.88. What is the ratio of the Balance of Payment (as % of service exports) in Philippines in 2008 to that in 2010?
Give a very brief answer. 0.9. What is the ratio of the Balance of Payment (as % of service exports) of Ukraine in 2008 to that in 2010?
Give a very brief answer. 0.7. What is the ratio of the Balance of Payment (as % of service exports) of East Asia (developing only) in 2008 to that in 2011?
Give a very brief answer. 0.86. What is the ratio of the Balance of Payment (as % of service exports) in Canada in 2008 to that in 2011?
Keep it short and to the point. 0.98. What is the ratio of the Balance of Payment (as % of service exports) of Philippines in 2008 to that in 2011?
Keep it short and to the point. 0.92. What is the ratio of the Balance of Payment (as % of service exports) in Ukraine in 2008 to that in 2011?
Provide a succinct answer. 0.68. What is the ratio of the Balance of Payment (as % of service exports) in East Asia (developing only) in 2008 to that in 2012?
Give a very brief answer. 0.89. What is the ratio of the Balance of Payment (as % of service exports) in Canada in 2008 to that in 2012?
Make the answer very short. 0.97. What is the ratio of the Balance of Payment (as % of service exports) in Philippines in 2008 to that in 2012?
Keep it short and to the point. 0.96. What is the ratio of the Balance of Payment (as % of service exports) of Ukraine in 2008 to that in 2012?
Offer a terse response. 0.63. What is the ratio of the Balance of Payment (as % of service exports) in East Asia (developing only) in 2009 to that in 2010?
Your response must be concise. 1. What is the ratio of the Balance of Payment (as % of service exports) of Canada in 2009 to that in 2010?
Give a very brief answer. 1.02. What is the ratio of the Balance of Payment (as % of service exports) of Philippines in 2009 to that in 2010?
Offer a very short reply. 0.97. What is the ratio of the Balance of Payment (as % of service exports) in Ukraine in 2009 to that in 2010?
Give a very brief answer. 0.83. What is the ratio of the Balance of Payment (as % of service exports) of East Asia (developing only) in 2009 to that in 2011?
Provide a succinct answer. 0.98. What is the ratio of the Balance of Payment (as % of service exports) of Canada in 2009 to that in 2011?
Keep it short and to the point. 1.03. What is the ratio of the Balance of Payment (as % of service exports) in Ukraine in 2009 to that in 2011?
Offer a very short reply. 0.8. What is the ratio of the Balance of Payment (as % of service exports) in East Asia (developing only) in 2009 to that in 2012?
Ensure brevity in your answer.  1.01. What is the ratio of the Balance of Payment (as % of service exports) in Canada in 2009 to that in 2012?
Make the answer very short. 1.01. What is the ratio of the Balance of Payment (as % of service exports) of Philippines in 2009 to that in 2012?
Provide a succinct answer. 1.04. What is the ratio of the Balance of Payment (as % of service exports) of Ukraine in 2009 to that in 2012?
Keep it short and to the point. 0.74. What is the ratio of the Balance of Payment (as % of service exports) in East Asia (developing only) in 2010 to that in 2011?
Your answer should be very brief. 0.98. What is the ratio of the Balance of Payment (as % of service exports) in Philippines in 2010 to that in 2011?
Give a very brief answer. 1.02. What is the ratio of the Balance of Payment (as % of service exports) in Ukraine in 2010 to that in 2011?
Keep it short and to the point. 0.97. What is the ratio of the Balance of Payment (as % of service exports) in East Asia (developing only) in 2010 to that in 2012?
Give a very brief answer. 1.01. What is the ratio of the Balance of Payment (as % of service exports) of Canada in 2010 to that in 2012?
Give a very brief answer. 0.99. What is the ratio of the Balance of Payment (as % of service exports) in Philippines in 2010 to that in 2012?
Keep it short and to the point. 1.07. What is the ratio of the Balance of Payment (as % of service exports) of Ukraine in 2010 to that in 2012?
Ensure brevity in your answer.  0.9. What is the ratio of the Balance of Payment (as % of service exports) in East Asia (developing only) in 2011 to that in 2012?
Your response must be concise. 1.03. What is the ratio of the Balance of Payment (as % of service exports) in Canada in 2011 to that in 2012?
Your answer should be very brief. 0.99. What is the ratio of the Balance of Payment (as % of service exports) in Philippines in 2011 to that in 2012?
Make the answer very short. 1.05. What is the ratio of the Balance of Payment (as % of service exports) of Ukraine in 2011 to that in 2012?
Give a very brief answer. 0.93. What is the difference between the highest and the second highest Balance of Payment (as % of service exports) in East Asia (developing only)?
Your response must be concise. 0.56. What is the difference between the highest and the second highest Balance of Payment (as % of service exports) in Canada?
Provide a succinct answer. 0.57. What is the difference between the highest and the second highest Balance of Payment (as % of service exports) in Philippines?
Your answer should be very brief. 1.39. What is the difference between the highest and the second highest Balance of Payment (as % of service exports) in Ukraine?
Your answer should be compact. 1.42. What is the difference between the highest and the lowest Balance of Payment (as % of service exports) in East Asia (developing only)?
Offer a very short reply. 6.18. What is the difference between the highest and the lowest Balance of Payment (as % of service exports) in Canada?
Offer a very short reply. 4.41. What is the difference between the highest and the lowest Balance of Payment (as % of service exports) in Philippines?
Keep it short and to the point. 22.41. What is the difference between the highest and the lowest Balance of Payment (as % of service exports) in Ukraine?
Your answer should be very brief. 10.38. 